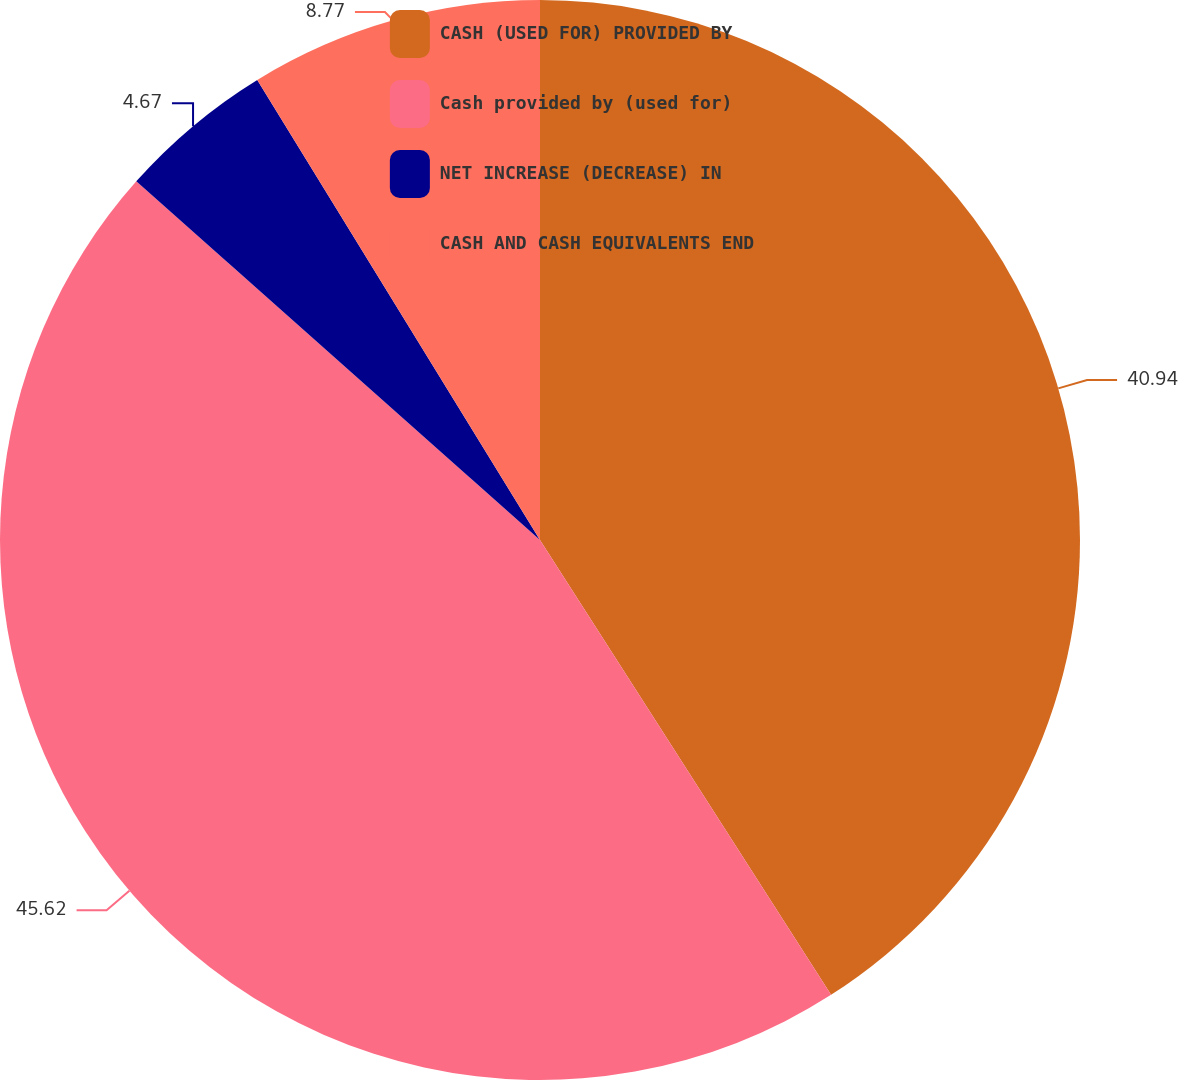Convert chart. <chart><loc_0><loc_0><loc_500><loc_500><pie_chart><fcel>CASH (USED FOR) PROVIDED BY<fcel>Cash provided by (used for)<fcel>NET INCREASE (DECREASE) IN<fcel>CASH AND CASH EQUIVALENTS END<nl><fcel>40.94%<fcel>45.62%<fcel>4.67%<fcel>8.77%<nl></chart> 